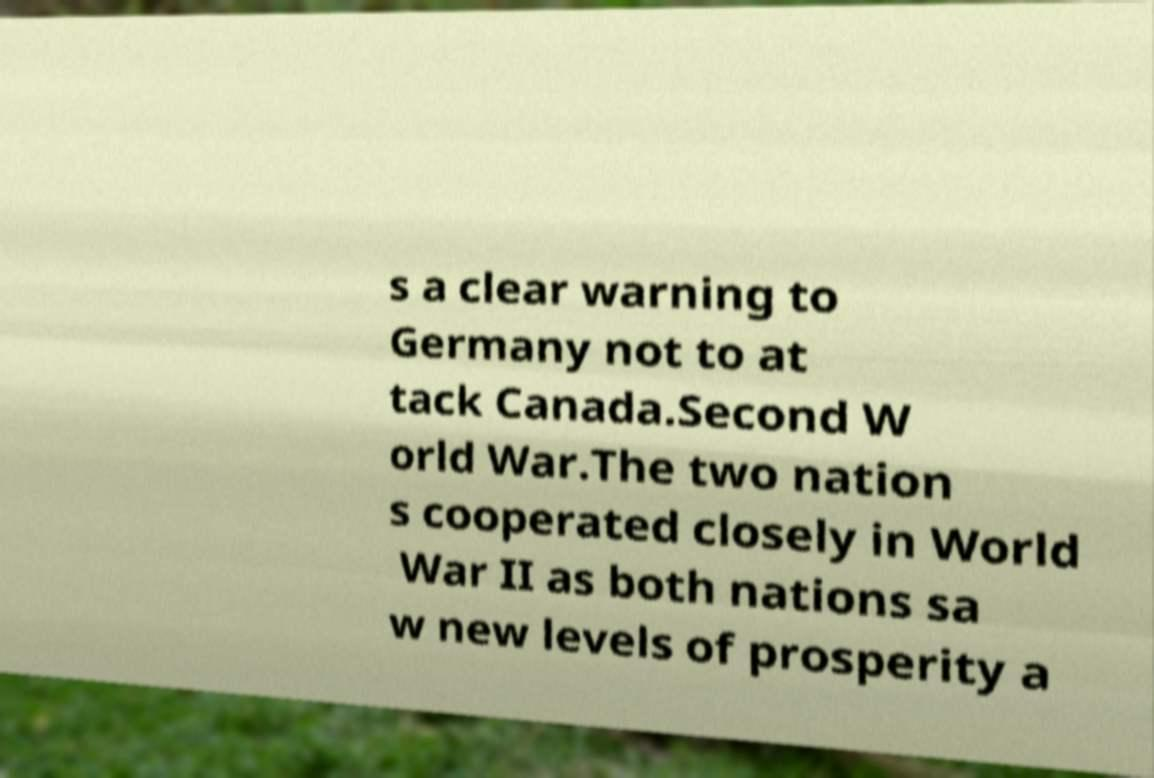There's text embedded in this image that I need extracted. Can you transcribe it verbatim? s a clear warning to Germany not to at tack Canada.Second W orld War.The two nation s cooperated closely in World War II as both nations sa w new levels of prosperity a 